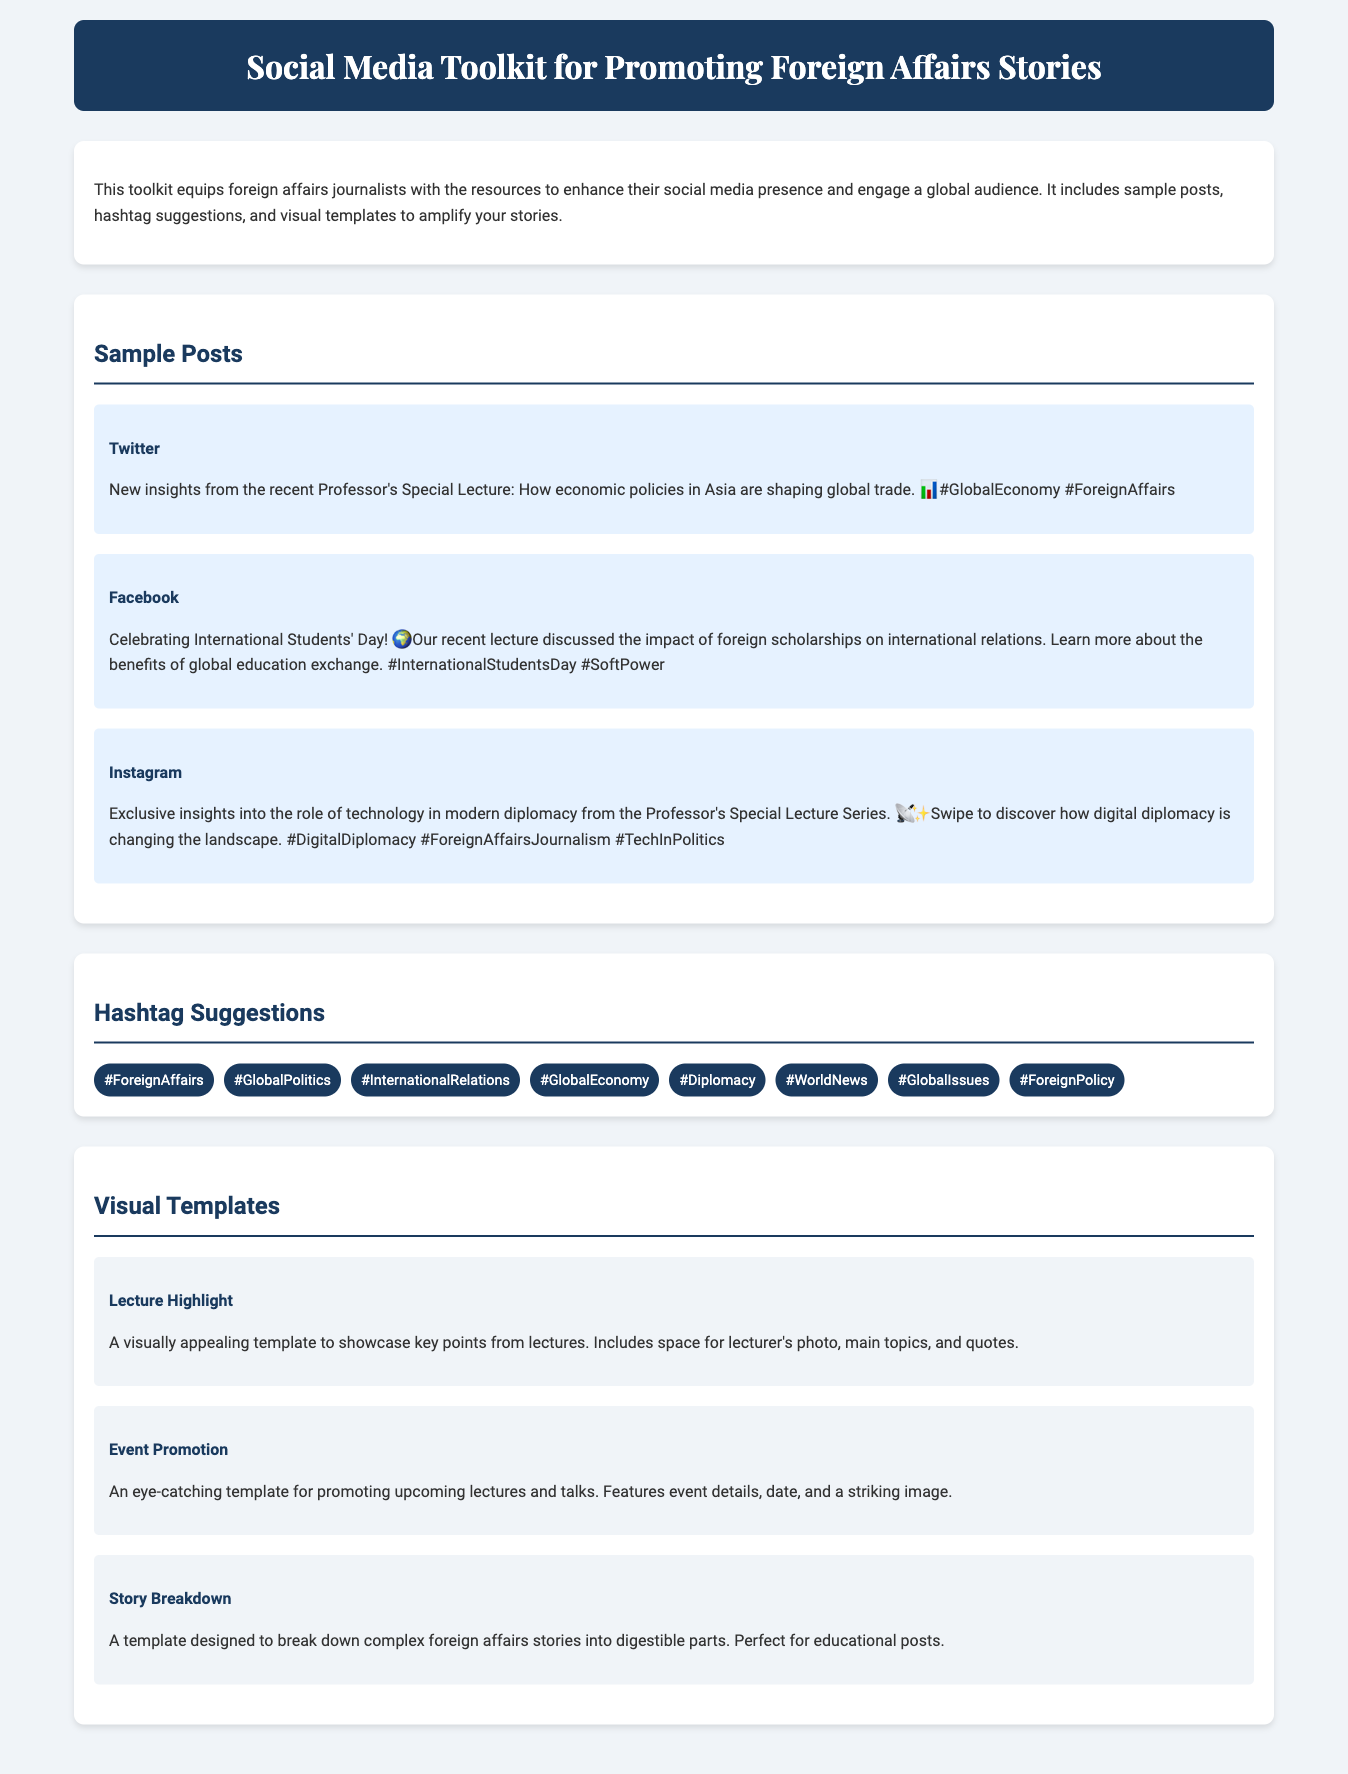what is the title of the document? The title of the document is provided in the header section of the HTML, stating the purpose of the toolkit.
Answer: Social Media Toolkit for Promoting Foreign Affairs Stories how many sample posts are provided in the document? The document lists three distinct sample posts under the Sample Posts section, showcasing different platforms.
Answer: 3 what is the platform mentioned for the first sample post? The document specifies the platform for each sample post, with the first one being Twitter.
Answer: Twitter which hashtag suggests a focus on economic matters? The document includes several hashtag suggestions, where #GlobalEconomy highlights economic issues.
Answer: #GlobalEconomy what is the name of the visual template for promoting events? The document outlines different visual templates, one of which is specifically designed for promoting events.
Answer: Event Promotion how many hashtags are suggested in total? The document lists a set of hashtags to use, counting all those presented in the Hashtag Suggestions section.
Answer: 8 what theme does the "Story Breakdown" template focus on? The "Story Breakdown" template is described as a tool for simplifying complex topics, indicating an educational focus.
Answer: Educational what social media platform is suggested for sharing exclusive insights? The document indicates Instagram as the platform suggested for posting exclusive insights.
Answer: Instagram which recent event is celebrated in the sample Facebook post? The Facebook post highlights an event related to international collaboration and education, specifically recognizing International Students' Day.
Answer: International Students' Day 